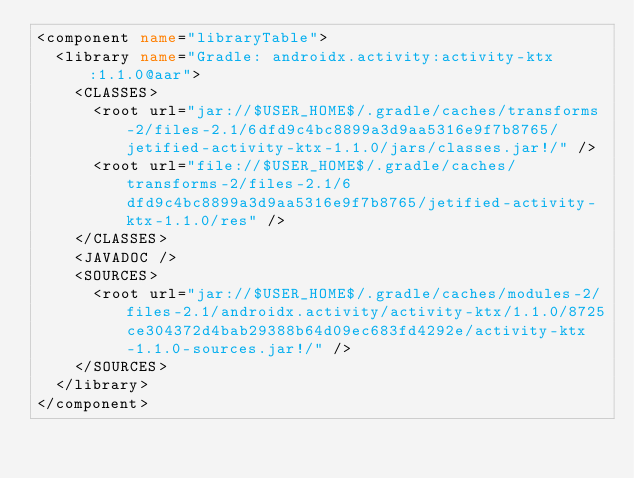<code> <loc_0><loc_0><loc_500><loc_500><_XML_><component name="libraryTable">
  <library name="Gradle: androidx.activity:activity-ktx:1.1.0@aar">
    <CLASSES>
      <root url="jar://$USER_HOME$/.gradle/caches/transforms-2/files-2.1/6dfd9c4bc8899a3d9aa5316e9f7b8765/jetified-activity-ktx-1.1.0/jars/classes.jar!/" />
      <root url="file://$USER_HOME$/.gradle/caches/transforms-2/files-2.1/6dfd9c4bc8899a3d9aa5316e9f7b8765/jetified-activity-ktx-1.1.0/res" />
    </CLASSES>
    <JAVADOC />
    <SOURCES>
      <root url="jar://$USER_HOME$/.gradle/caches/modules-2/files-2.1/androidx.activity/activity-ktx/1.1.0/8725ce304372d4bab29388b64d09ec683fd4292e/activity-ktx-1.1.0-sources.jar!/" />
    </SOURCES>
  </library>
</component></code> 